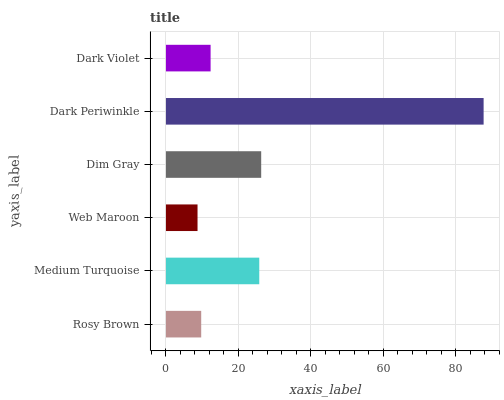Is Web Maroon the minimum?
Answer yes or no. Yes. Is Dark Periwinkle the maximum?
Answer yes or no. Yes. Is Medium Turquoise the minimum?
Answer yes or no. No. Is Medium Turquoise the maximum?
Answer yes or no. No. Is Medium Turquoise greater than Rosy Brown?
Answer yes or no. Yes. Is Rosy Brown less than Medium Turquoise?
Answer yes or no. Yes. Is Rosy Brown greater than Medium Turquoise?
Answer yes or no. No. Is Medium Turquoise less than Rosy Brown?
Answer yes or no. No. Is Medium Turquoise the high median?
Answer yes or no. Yes. Is Dark Violet the low median?
Answer yes or no. Yes. Is Web Maroon the high median?
Answer yes or no. No. Is Dim Gray the low median?
Answer yes or no. No. 